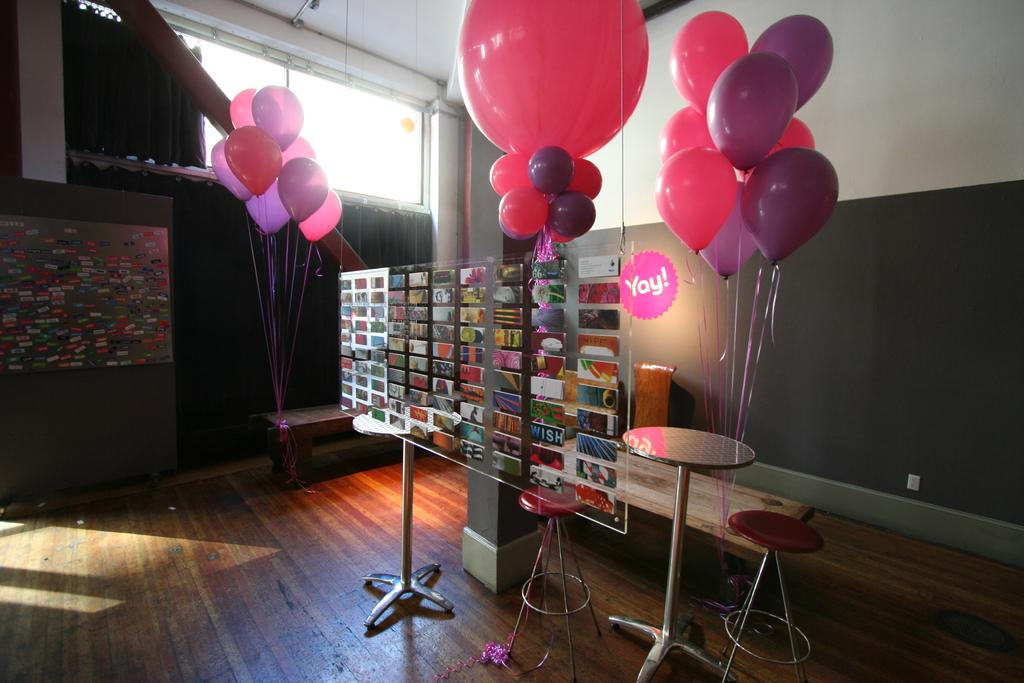<image>
Present a compact description of the photo's key features. Display stand with different cards in front of a round pink sticker Yay! 